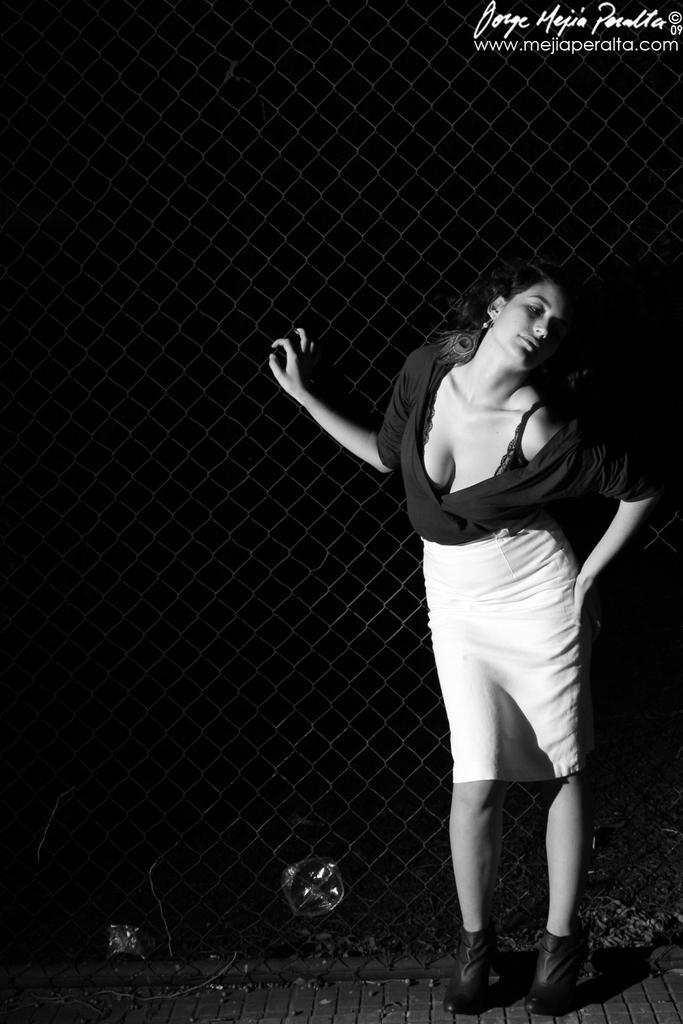Describe this image in one or two sentences. This is a black and white pic. On the right side we can see a woman is standing on the ground and placed her hand on a mesh. In the background the image is dark but we can see an object. At the top we can see a text written on the image. 